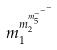Convert formula to latex. <formula><loc_0><loc_0><loc_500><loc_500>m _ { 1 } ^ { m _ { 2 } ^ { m _ { 5 } ^ { - ^ { - ^ { - } } } } }</formula> 